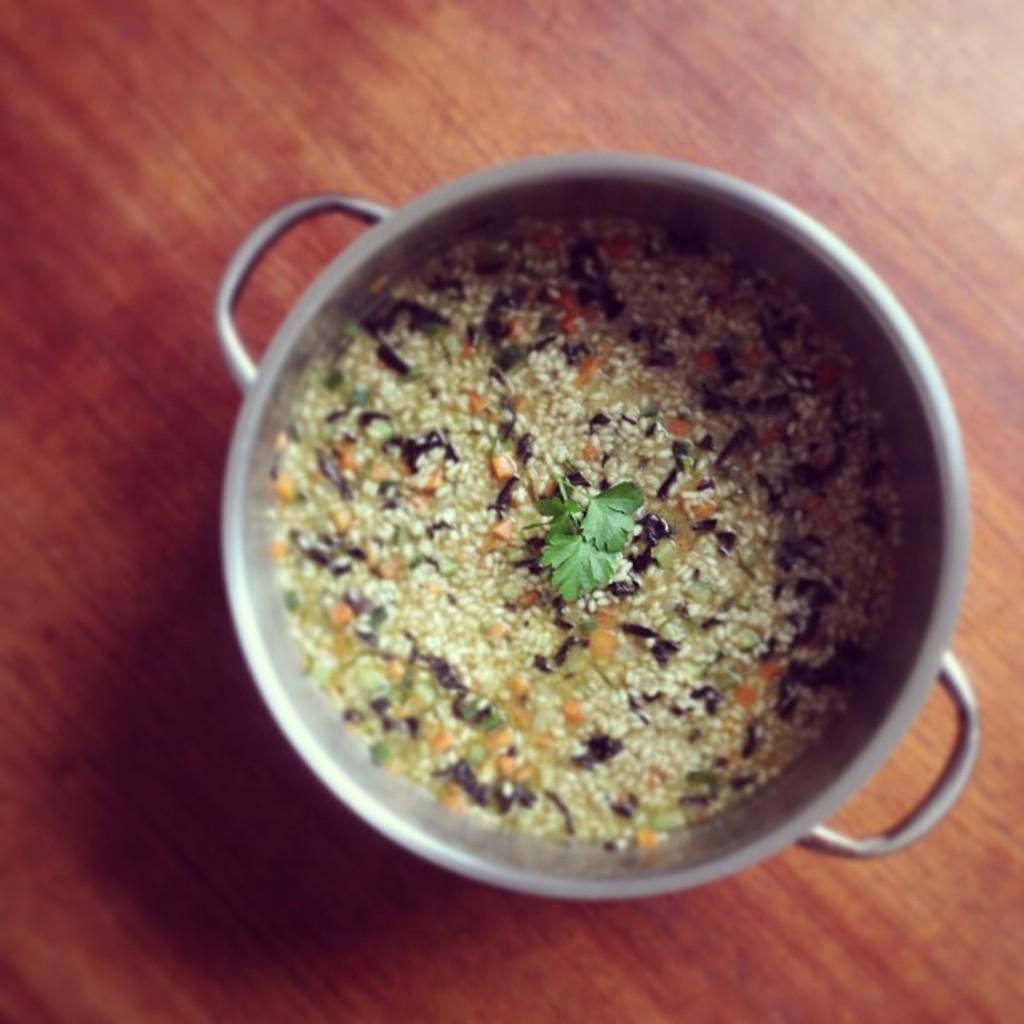Can you describe this image briefly? In this picture there is an edible placed in a vessel which is on a table. 